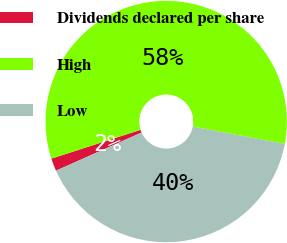Convert chart. <chart><loc_0><loc_0><loc_500><loc_500><pie_chart><fcel>Dividends declared per share<fcel>High<fcel>Low<nl><fcel>1.71%<fcel>57.94%<fcel>40.35%<nl></chart> 